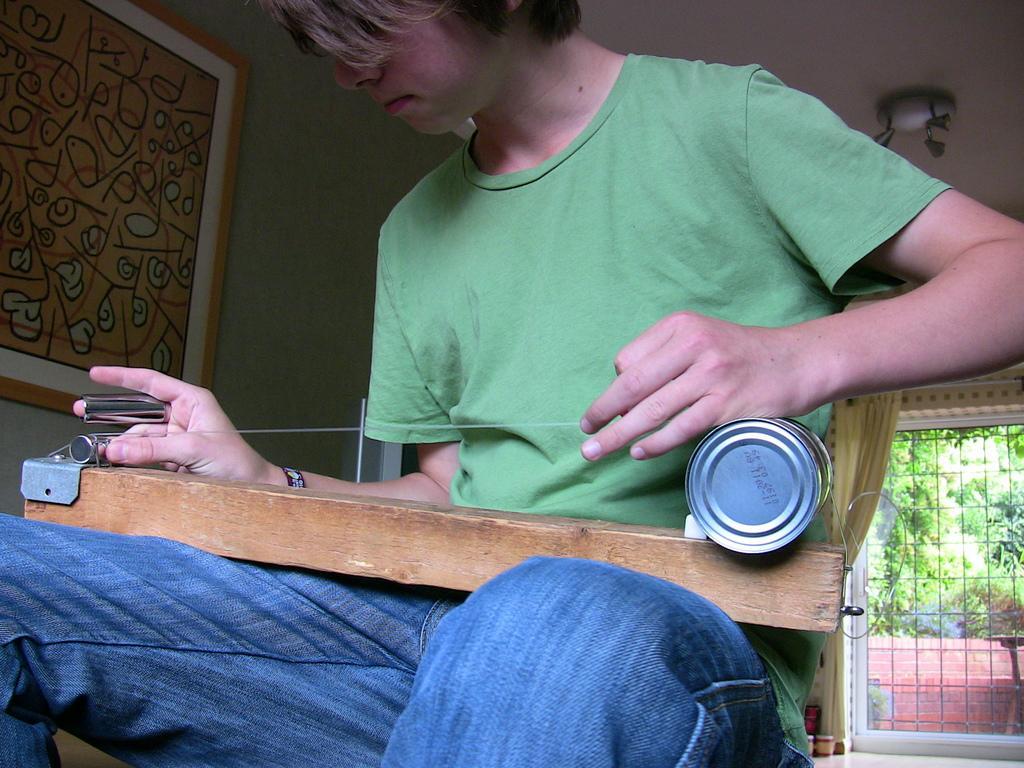In one or two sentences, can you explain what this image depicts? This image is taken indoors. In the background there is a wall with a picture frame, a door and a curtain. There are a few grills. At the top of the image there is a ceiling. In the middle of the image a boy is sitting and he is holding a rat trapper in his hands. 